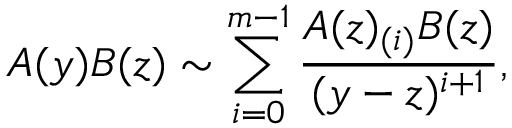<formula> <loc_0><loc_0><loc_500><loc_500>A ( y ) B ( z ) \sim \sum _ { i = 0 } ^ { m - 1 } \frac { A ( z ) _ { ( i ) } B ( z ) } { ( y - z ) ^ { i + 1 } } ,</formula> 